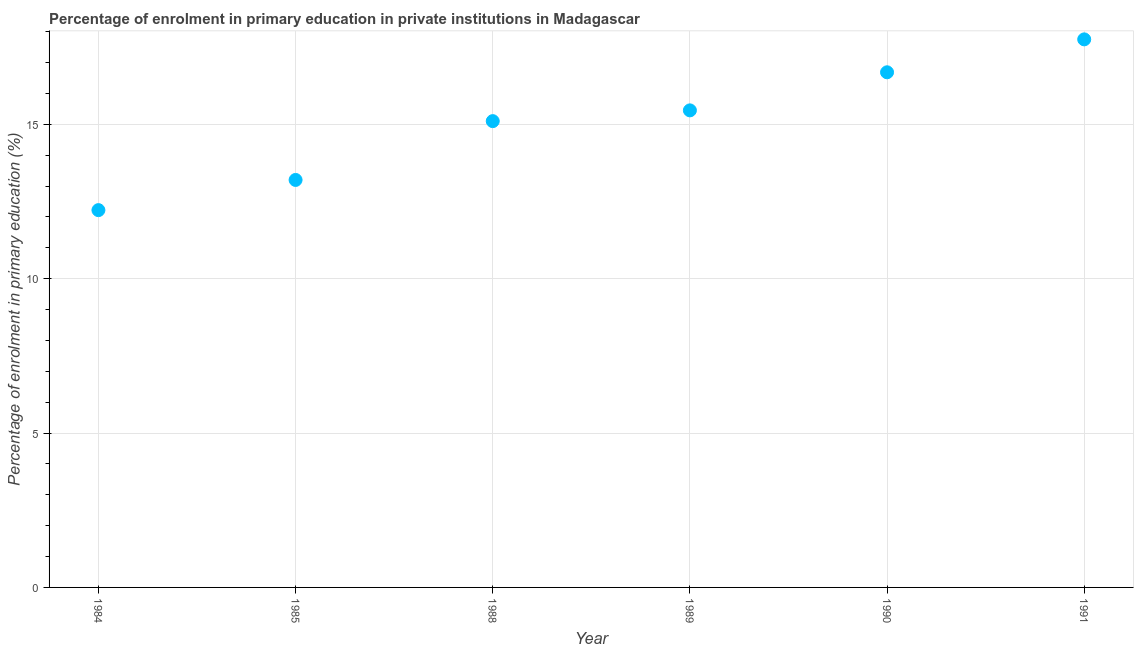What is the enrolment percentage in primary education in 1991?
Your answer should be compact. 17.75. Across all years, what is the maximum enrolment percentage in primary education?
Provide a succinct answer. 17.75. Across all years, what is the minimum enrolment percentage in primary education?
Your answer should be very brief. 12.22. In which year was the enrolment percentage in primary education minimum?
Provide a short and direct response. 1984. What is the sum of the enrolment percentage in primary education?
Ensure brevity in your answer.  90.4. What is the difference between the enrolment percentage in primary education in 1984 and 1985?
Offer a terse response. -0.98. What is the average enrolment percentage in primary education per year?
Your response must be concise. 15.07. What is the median enrolment percentage in primary education?
Provide a short and direct response. 15.28. In how many years, is the enrolment percentage in primary education greater than 2 %?
Ensure brevity in your answer.  6. Do a majority of the years between 1985 and 1989 (inclusive) have enrolment percentage in primary education greater than 7 %?
Your response must be concise. Yes. What is the ratio of the enrolment percentage in primary education in 1984 to that in 1989?
Make the answer very short. 0.79. Is the enrolment percentage in primary education in 1989 less than that in 1990?
Provide a succinct answer. Yes. What is the difference between the highest and the second highest enrolment percentage in primary education?
Make the answer very short. 1.07. What is the difference between the highest and the lowest enrolment percentage in primary education?
Provide a succinct answer. 5.53. In how many years, is the enrolment percentage in primary education greater than the average enrolment percentage in primary education taken over all years?
Your answer should be compact. 4. Does the enrolment percentage in primary education monotonically increase over the years?
Offer a very short reply. Yes. How many years are there in the graph?
Ensure brevity in your answer.  6. Are the values on the major ticks of Y-axis written in scientific E-notation?
Your answer should be compact. No. Does the graph contain any zero values?
Offer a terse response. No. Does the graph contain grids?
Ensure brevity in your answer.  Yes. What is the title of the graph?
Ensure brevity in your answer.  Percentage of enrolment in primary education in private institutions in Madagascar. What is the label or title of the X-axis?
Offer a terse response. Year. What is the label or title of the Y-axis?
Provide a short and direct response. Percentage of enrolment in primary education (%). What is the Percentage of enrolment in primary education (%) in 1984?
Your response must be concise. 12.22. What is the Percentage of enrolment in primary education (%) in 1985?
Keep it short and to the point. 13.2. What is the Percentage of enrolment in primary education (%) in 1988?
Ensure brevity in your answer.  15.1. What is the Percentage of enrolment in primary education (%) in 1989?
Your response must be concise. 15.45. What is the Percentage of enrolment in primary education (%) in 1990?
Your response must be concise. 16.68. What is the Percentage of enrolment in primary education (%) in 1991?
Provide a succinct answer. 17.75. What is the difference between the Percentage of enrolment in primary education (%) in 1984 and 1985?
Keep it short and to the point. -0.98. What is the difference between the Percentage of enrolment in primary education (%) in 1984 and 1988?
Offer a very short reply. -2.88. What is the difference between the Percentage of enrolment in primary education (%) in 1984 and 1989?
Give a very brief answer. -3.23. What is the difference between the Percentage of enrolment in primary education (%) in 1984 and 1990?
Offer a terse response. -4.46. What is the difference between the Percentage of enrolment in primary education (%) in 1984 and 1991?
Provide a short and direct response. -5.53. What is the difference between the Percentage of enrolment in primary education (%) in 1985 and 1988?
Your answer should be very brief. -1.9. What is the difference between the Percentage of enrolment in primary education (%) in 1985 and 1989?
Make the answer very short. -2.25. What is the difference between the Percentage of enrolment in primary education (%) in 1985 and 1990?
Your answer should be very brief. -3.49. What is the difference between the Percentage of enrolment in primary education (%) in 1985 and 1991?
Provide a succinct answer. -4.55. What is the difference between the Percentage of enrolment in primary education (%) in 1988 and 1989?
Your response must be concise. -0.35. What is the difference between the Percentage of enrolment in primary education (%) in 1988 and 1990?
Provide a short and direct response. -1.58. What is the difference between the Percentage of enrolment in primary education (%) in 1988 and 1991?
Your response must be concise. -2.65. What is the difference between the Percentage of enrolment in primary education (%) in 1989 and 1990?
Give a very brief answer. -1.23. What is the difference between the Percentage of enrolment in primary education (%) in 1989 and 1991?
Offer a very short reply. -2.3. What is the difference between the Percentage of enrolment in primary education (%) in 1990 and 1991?
Keep it short and to the point. -1.07. What is the ratio of the Percentage of enrolment in primary education (%) in 1984 to that in 1985?
Make the answer very short. 0.93. What is the ratio of the Percentage of enrolment in primary education (%) in 1984 to that in 1988?
Provide a short and direct response. 0.81. What is the ratio of the Percentage of enrolment in primary education (%) in 1984 to that in 1989?
Keep it short and to the point. 0.79. What is the ratio of the Percentage of enrolment in primary education (%) in 1984 to that in 1990?
Provide a short and direct response. 0.73. What is the ratio of the Percentage of enrolment in primary education (%) in 1984 to that in 1991?
Your answer should be compact. 0.69. What is the ratio of the Percentage of enrolment in primary education (%) in 1985 to that in 1988?
Provide a succinct answer. 0.87. What is the ratio of the Percentage of enrolment in primary education (%) in 1985 to that in 1989?
Keep it short and to the point. 0.85. What is the ratio of the Percentage of enrolment in primary education (%) in 1985 to that in 1990?
Ensure brevity in your answer.  0.79. What is the ratio of the Percentage of enrolment in primary education (%) in 1985 to that in 1991?
Give a very brief answer. 0.74. What is the ratio of the Percentage of enrolment in primary education (%) in 1988 to that in 1989?
Your answer should be compact. 0.98. What is the ratio of the Percentage of enrolment in primary education (%) in 1988 to that in 1990?
Keep it short and to the point. 0.91. What is the ratio of the Percentage of enrolment in primary education (%) in 1988 to that in 1991?
Offer a terse response. 0.85. What is the ratio of the Percentage of enrolment in primary education (%) in 1989 to that in 1990?
Your response must be concise. 0.93. What is the ratio of the Percentage of enrolment in primary education (%) in 1989 to that in 1991?
Keep it short and to the point. 0.87. What is the ratio of the Percentage of enrolment in primary education (%) in 1990 to that in 1991?
Make the answer very short. 0.94. 